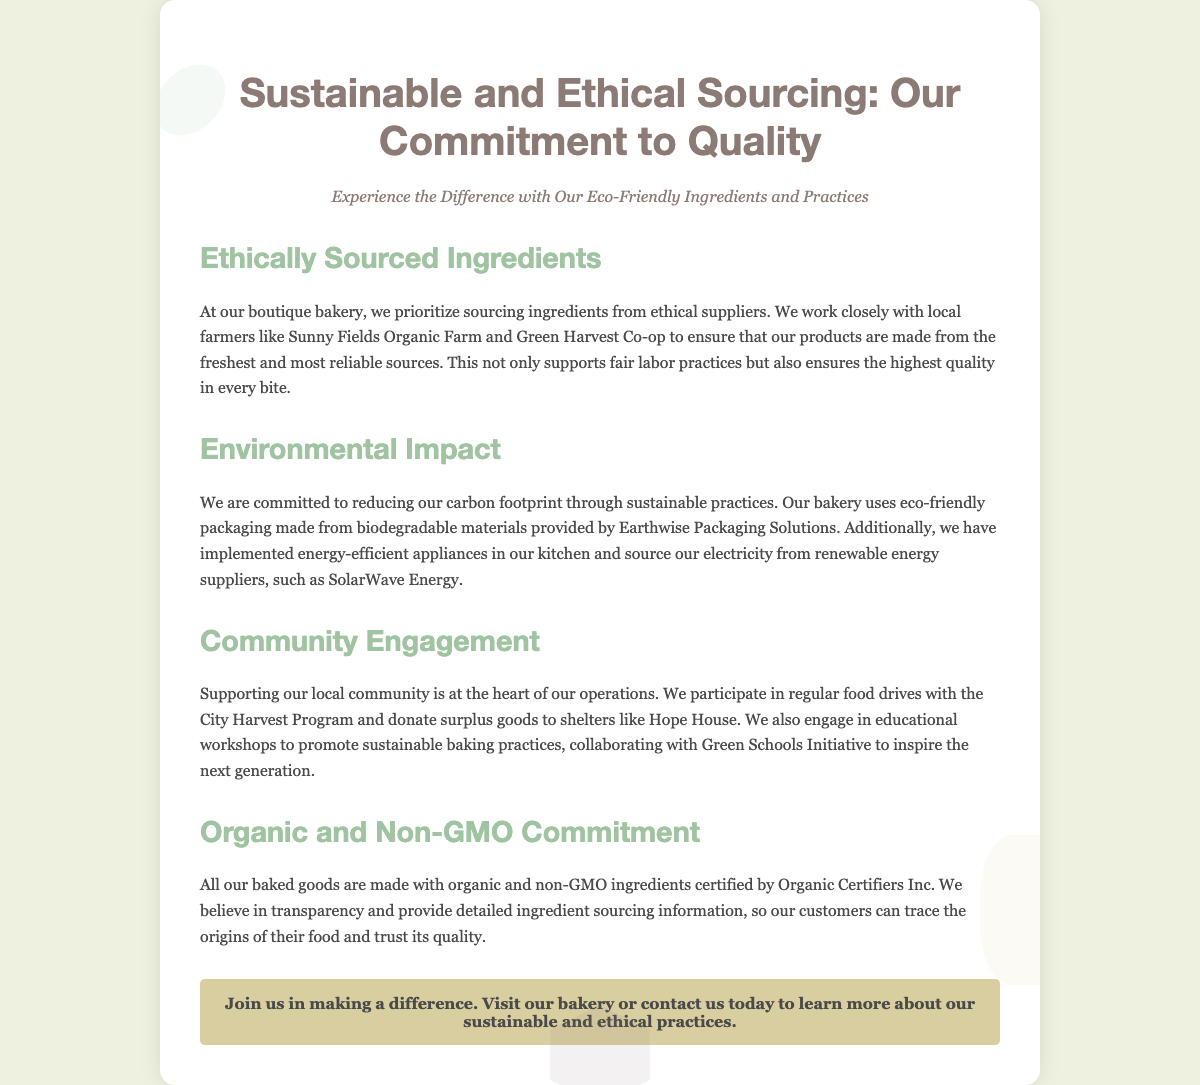What is the title of the flyer? The title of the flyer is prominently displayed at the top of the document.
Answer: Sustainable and Ethical Sourcing: Our Commitment to Quality Who are two of the local suppliers mentioned? The document specifically names local suppliers that the bakery works with for its ingredients.
Answer: Sunny Fields Organic Farm and Green Harvest Co-op What type of packaging does the bakery use? The flyer details the packaging materials used by the bakery, emphasizing sustainability.
Answer: Eco-friendly packaging made from biodegradable materials What commitment does the bakery have regarding ingredients? The bakery's promise regarding its ingredients is explicitly mentioned in one section of the flyer.
Answer: Organic and non-GMO What action does the bakery participate in for community support? The flyer mentions specific community engagement initiatives undertaken by the bakery.
Answer: Food drives with the City Harvest Program What environmental actions are implemented in the bakery? The document outlines specific practices the bakery has adopted to minimize its environmental impact.
Answer: Energy-efficient appliances and renewable energy sourcing What organization certifies the bakery's ingredients? The source of certification for the bakery's ingredients is identified in the document.
Answer: Organic Certifiers Inc 